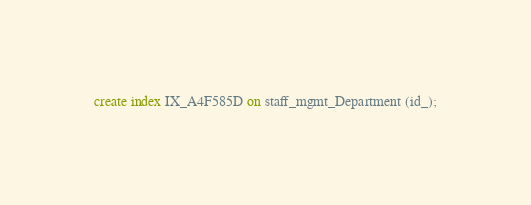Convert code to text. <code><loc_0><loc_0><loc_500><loc_500><_SQL_>create index IX_A4F585D on staff_mgmt_Department (id_);</code> 